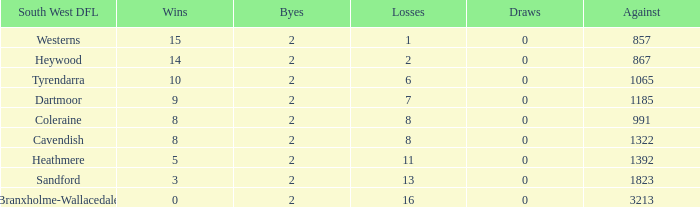How many successes have 16 setbacks and an against smaller than 3213? None. 